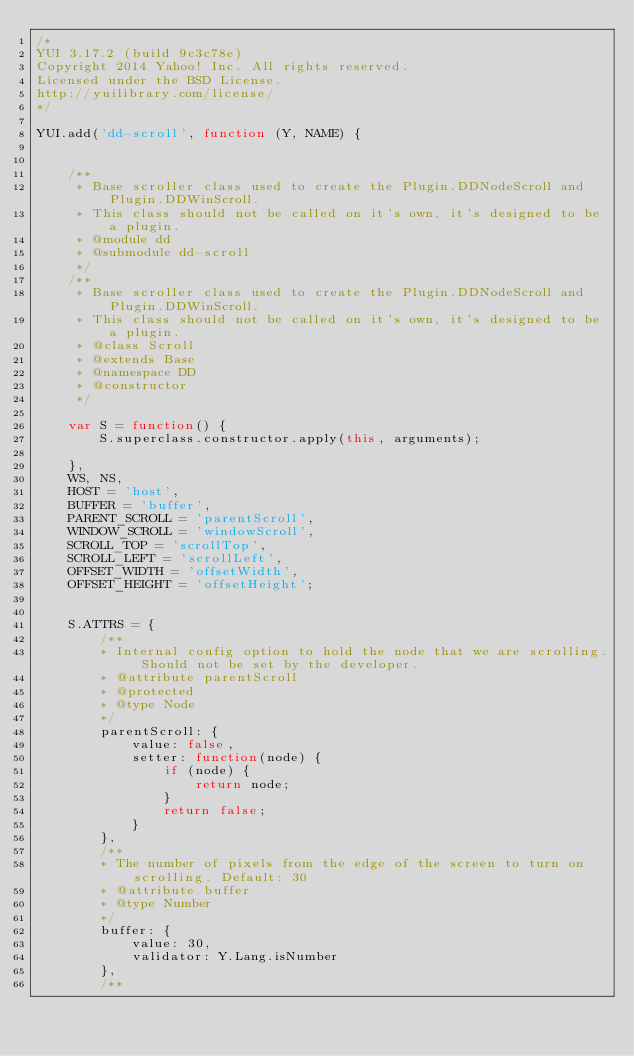<code> <loc_0><loc_0><loc_500><loc_500><_JavaScript_>/*
YUI 3.17.2 (build 9c3c78e)
Copyright 2014 Yahoo! Inc. All rights reserved.
Licensed under the BSD License.
http://yuilibrary.com/license/
*/

YUI.add('dd-scroll', function (Y, NAME) {


    /**
     * Base scroller class used to create the Plugin.DDNodeScroll and Plugin.DDWinScroll.
     * This class should not be called on it's own, it's designed to be a plugin.
     * @module dd
     * @submodule dd-scroll
     */
    /**
     * Base scroller class used to create the Plugin.DDNodeScroll and Plugin.DDWinScroll.
     * This class should not be called on it's own, it's designed to be a plugin.
     * @class Scroll
     * @extends Base
     * @namespace DD
     * @constructor
     */

    var S = function() {
        S.superclass.constructor.apply(this, arguments);

    },
    WS, NS,
    HOST = 'host',
    BUFFER = 'buffer',
    PARENT_SCROLL = 'parentScroll',
    WINDOW_SCROLL = 'windowScroll',
    SCROLL_TOP = 'scrollTop',
    SCROLL_LEFT = 'scrollLeft',
    OFFSET_WIDTH = 'offsetWidth',
    OFFSET_HEIGHT = 'offsetHeight';


    S.ATTRS = {
        /**
        * Internal config option to hold the node that we are scrolling. Should not be set by the developer.
        * @attribute parentScroll
        * @protected
        * @type Node
        */
        parentScroll: {
            value: false,
            setter: function(node) {
                if (node) {
                    return node;
                }
                return false;
            }
        },
        /**
        * The number of pixels from the edge of the screen to turn on scrolling. Default: 30
        * @attribute buffer
        * @type Number
        */
        buffer: {
            value: 30,
            validator: Y.Lang.isNumber
        },
        /**</code> 